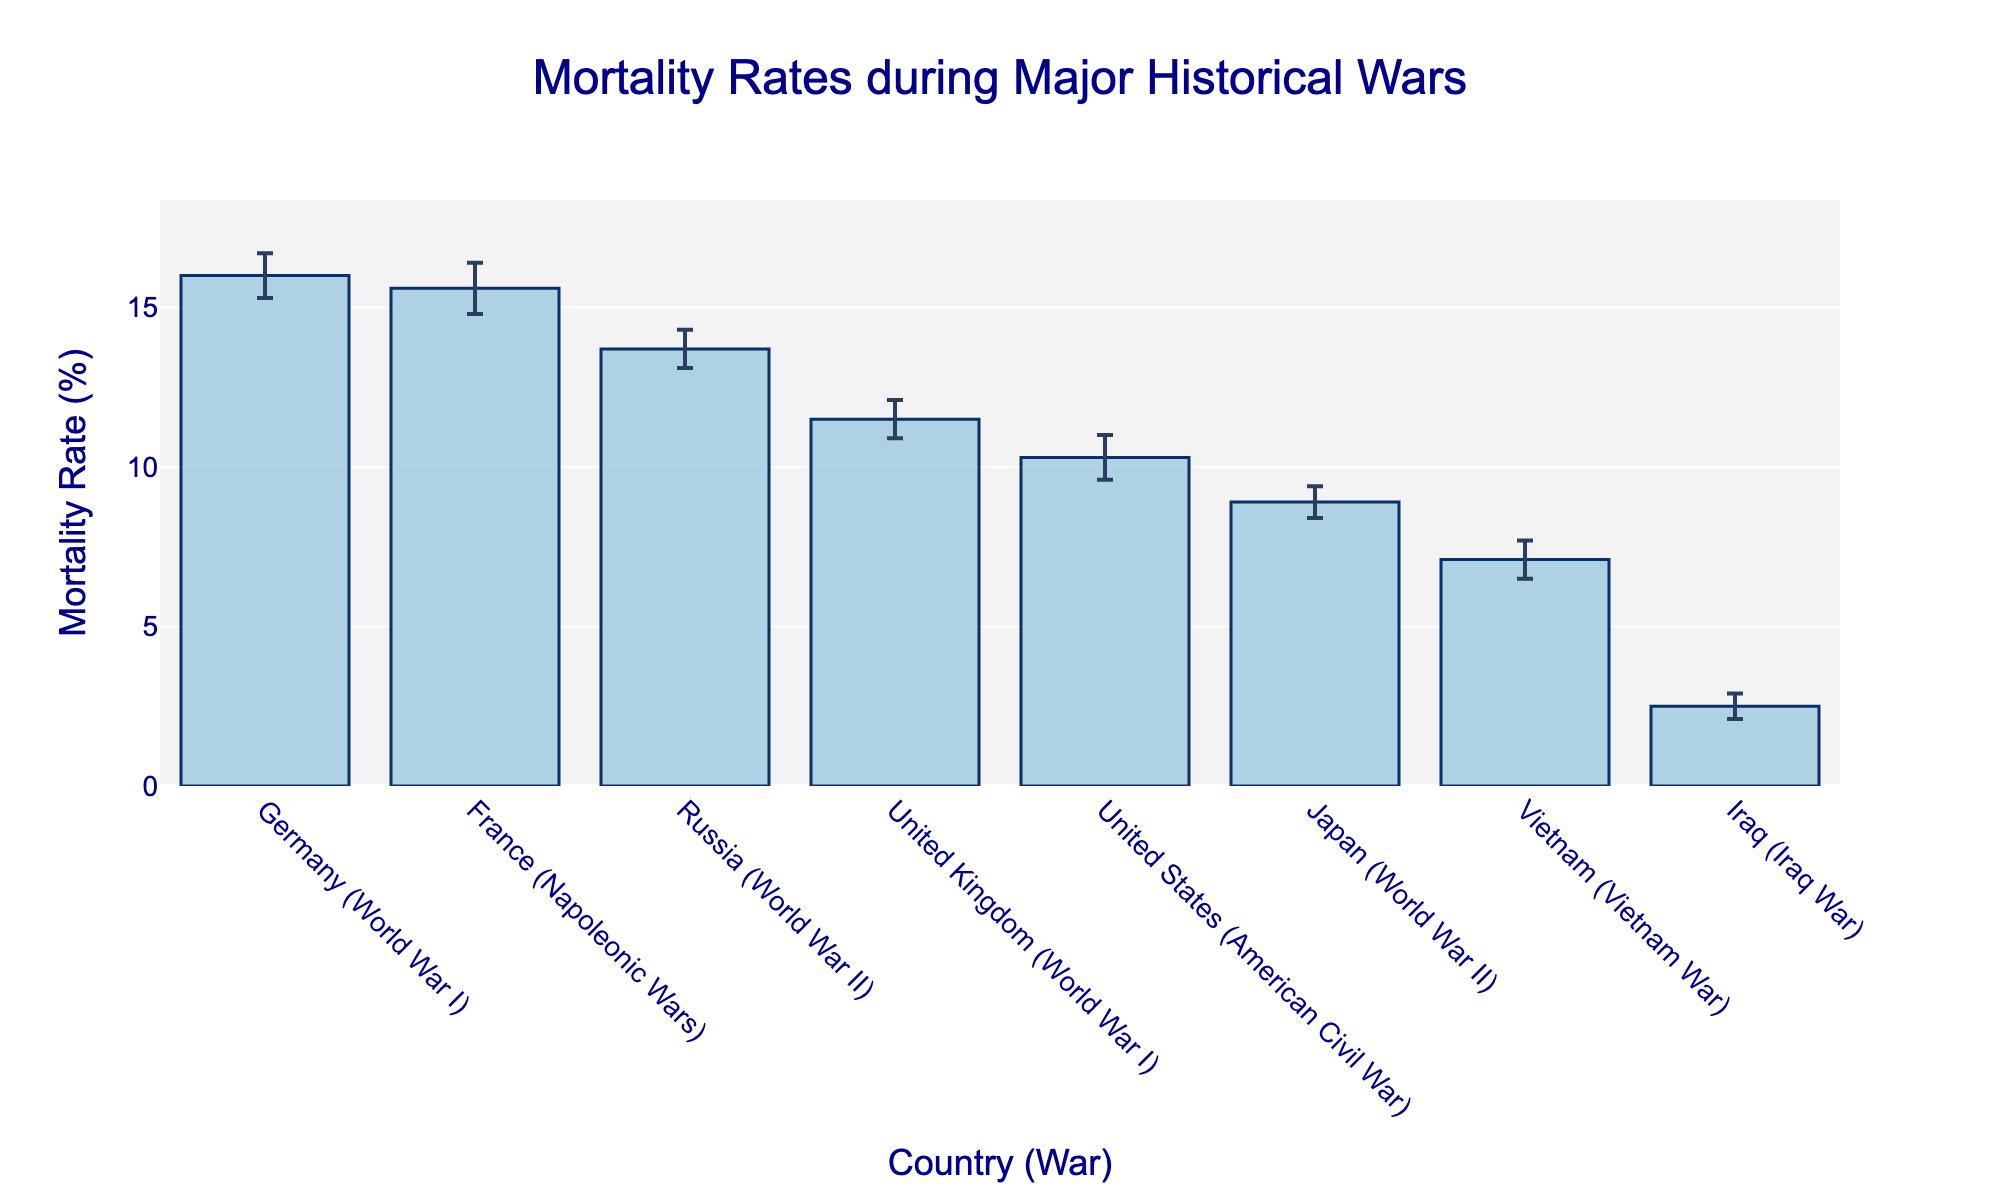Which country has the highest mean mortality rate during the historical wars shown? France has the highest mean mortality rate during the Napoleonic Wars, as seen by the bar that extends the highest on the plot.
Answer: France Which country has the lowest mean mortality rate during the historical wars shown? Iraq has the lowest mean mortality rate during the Iraq War, as indicated by the shortest bar on the plot.
Answer: Iraq What is the range of the 95% confidence interval for the United States during the American Civil War? To find the range, subtract the lower limit of the confidence interval (9.6%) from the upper limit (11.0%). So, 11.0% - 9.6% = 1.4%.
Answer: 1.4% Which war shows a higher mean mortality rate for World War I, the United Kingdom or Germany? The bar for Germany in World War I is higher than the bar for the United Kingdom in the same war, indicating a higher mean mortality rate for Germany.
Answer: Germany What is the difference in mean mortality rates between Japan in World War II and Vietnam in the Vietnam War? The mean mortality rate for Japan in World War II is 8.9%, and for Vietnam in the Vietnam War, it is 7.1%. The difference is 8.9% - 7.1% = 1.8%.
Answer: 1.8% Which country has a wider confidence interval, Russia during World War II or Japan during World War II? The confidence interval for Russia during World War II ranges from 13.1% to 14.3%, a span of 1.2%. For Japan during World War II, it ranges from 8.4% to 9.4%, a span of 1.0%. Thus, Russia has a wider confidence interval.
Answer: Russia What is the average mean mortality rate of the listed wars? The sum of the mean mortality rates is 15.6 + 11.5 + 16.0 + 10.3 + 13.7 + 8.9 + 7.1 + 2.5 = 85.6%. There are 8 wars, so the average is 85.6 / 8 = 10.7%.
Answer: 10.7% How does the mortality rate for the American Civil War compare to that of World War II for Russia? The mean mortality rate for the American Civil War (United States) is 10.3%, and for World War II (Russia) is 13.7%. So, the mortality rate for World War II (Russia) is higher.
Answer: World War II (Russia) Which wars have a mean mortality rate higher than the overall average? Wars with a mean mortality rate higher than the average of 10.7% are the Napoleonic Wars (France), World War I (United Kingdom), World War I (Germany), and World War II (Russia).
Answer: Napoleonic Wars, World War I (United Kingdom), World War I (Germany), World War II (Russia) What is the total length of the 95% confidence interval for France during the Napoleonic Wars? The 95% confidence interval ranges from 14.8% to 16.4%, giving a total length of 16.4% - 14.8% = 1.6%.
Answer: 1.6% 